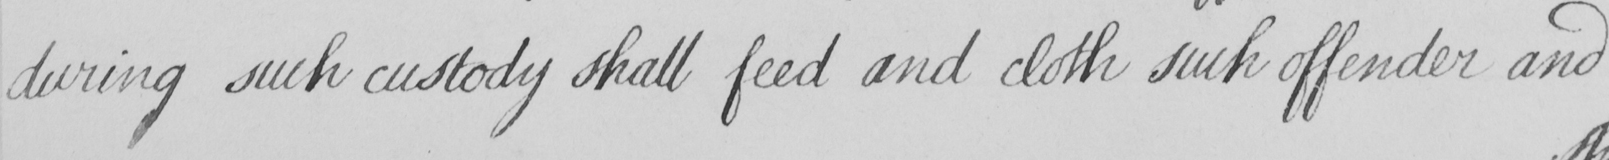What does this handwritten line say? during such custody shall feed and cloth such offender and 